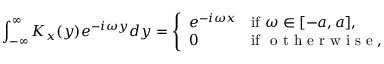Convert formula to latex. <formula><loc_0><loc_0><loc_500><loc_500>\int _ { - \infty } ^ { \infty } K _ { x } ( y ) e ^ { - i \omega y } d y = { \left \{ \begin{array} { l l } { e ^ { - i \omega x } } & { { i f } \omega \in [ - a , a ] , } \\ { 0 } & { { i f } { o t h e r w i s e } , } \end{array} }</formula> 